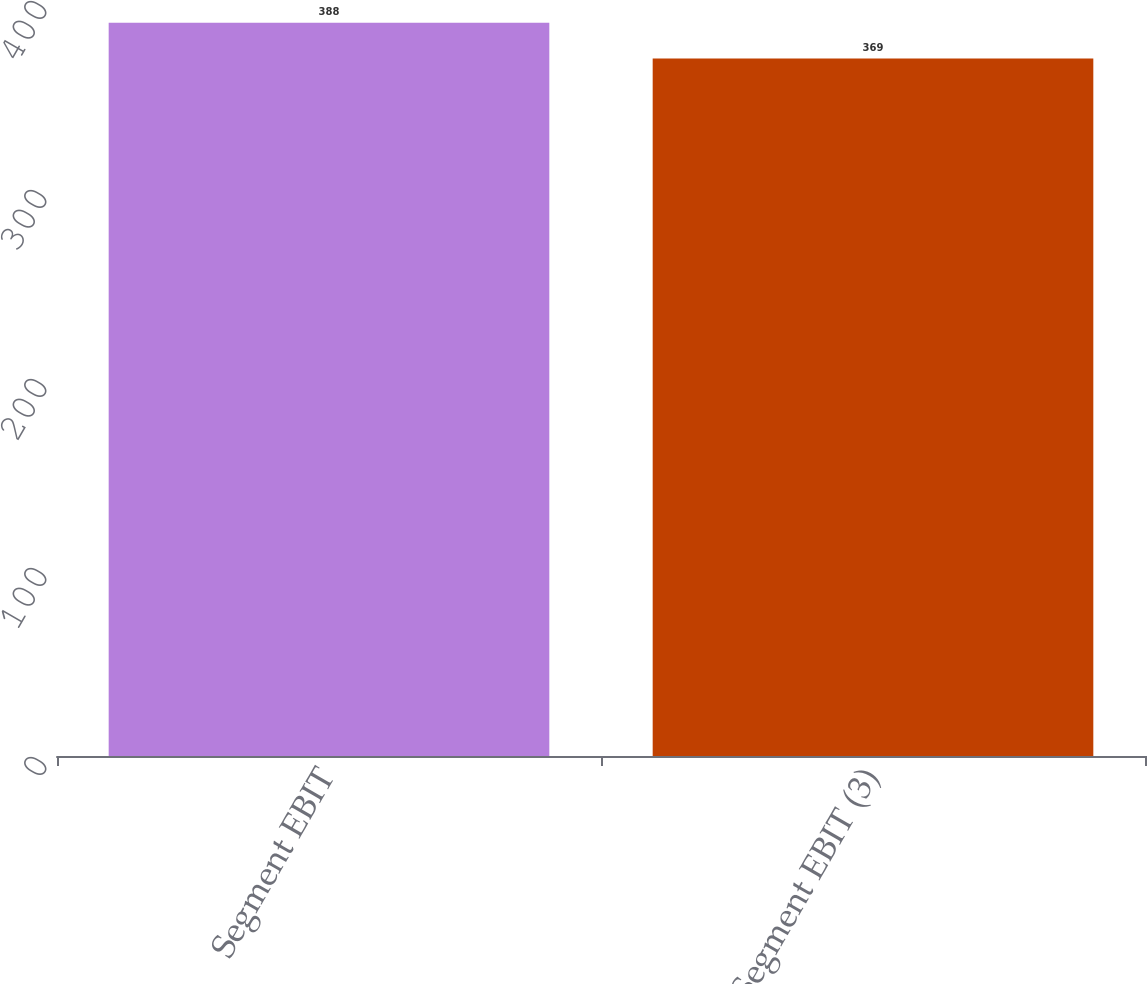Convert chart to OTSL. <chart><loc_0><loc_0><loc_500><loc_500><bar_chart><fcel>Segment EBIT<fcel>Segment EBIT (3)<nl><fcel>388<fcel>369<nl></chart> 